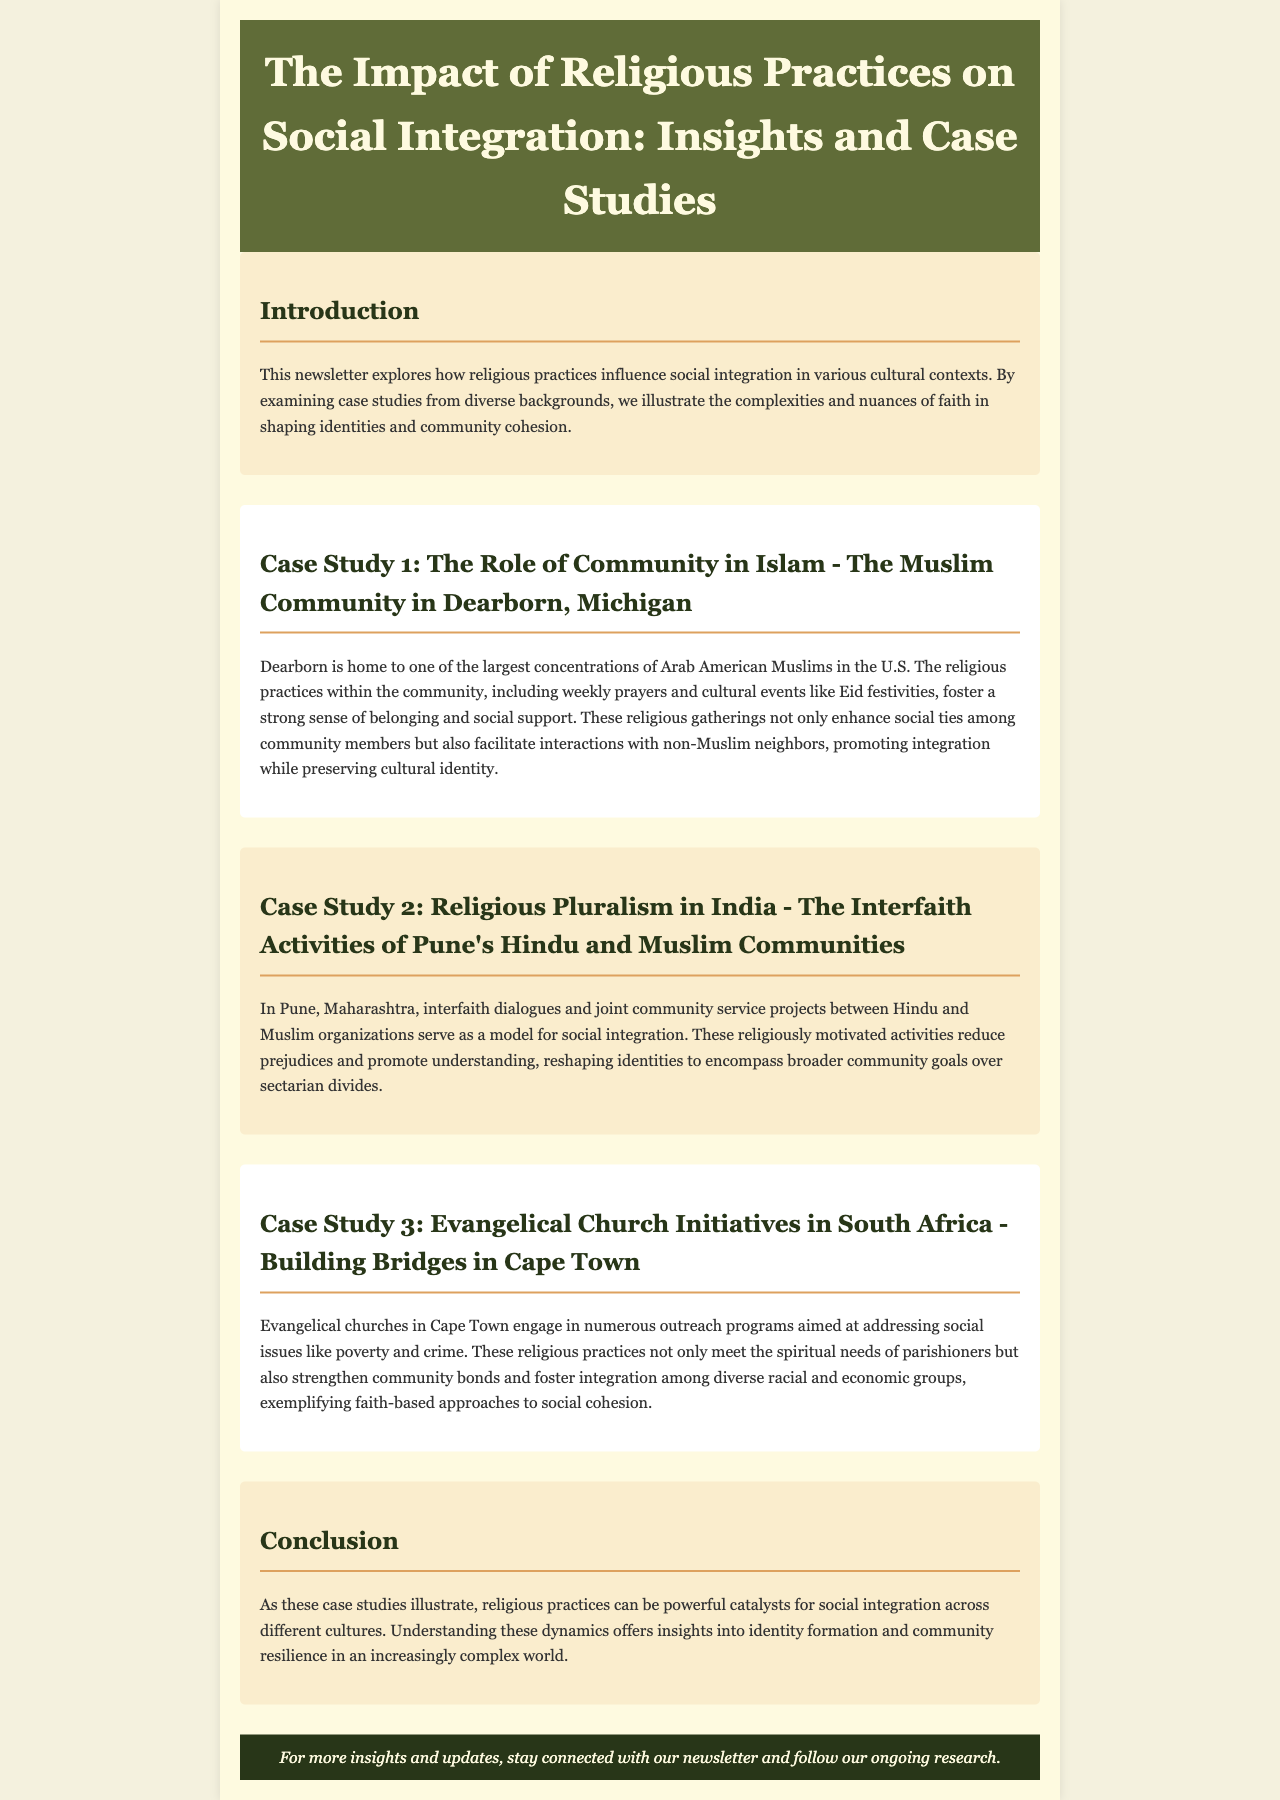What is the main focus of this newsletter? The newsletter examines how religious practices influence social integration in various cultural contexts.
Answer: Social integration Where is the Muslim community case study located? The case study discusses the Muslim community in Dearborn, Michigan.
Answer: Dearborn, Michigan What religious practices are mentioned in the Muslim community case study? The practices include weekly prayers and cultural events like Eid festivities.
Answer: Weekly prayers and Eid festivities Which two communities are involved in interfaith activities in Pune, India? The communities involved are Hindu and Muslim organizations.
Answer: Hindu and Muslim What social issues do the evangelical churches in Cape Town address? The evangelical churches address social issues like poverty and crime.
Answer: Poverty and crime What is the conclusion drawn about religious practices and social integration? The conclusion indicates that religious practices can be powerful catalysts for social integration across different cultures.
Answer: Powerful catalysts What is the purpose of the community service projects mentioned in the interfaith activities case study? These projects serve as a model for social integration and reduce prejudices.
Answer: Model for social integration What type of newsletter is this document categorized as? The document is categorized as a newsletter that explores research topics.
Answer: Newsletter 